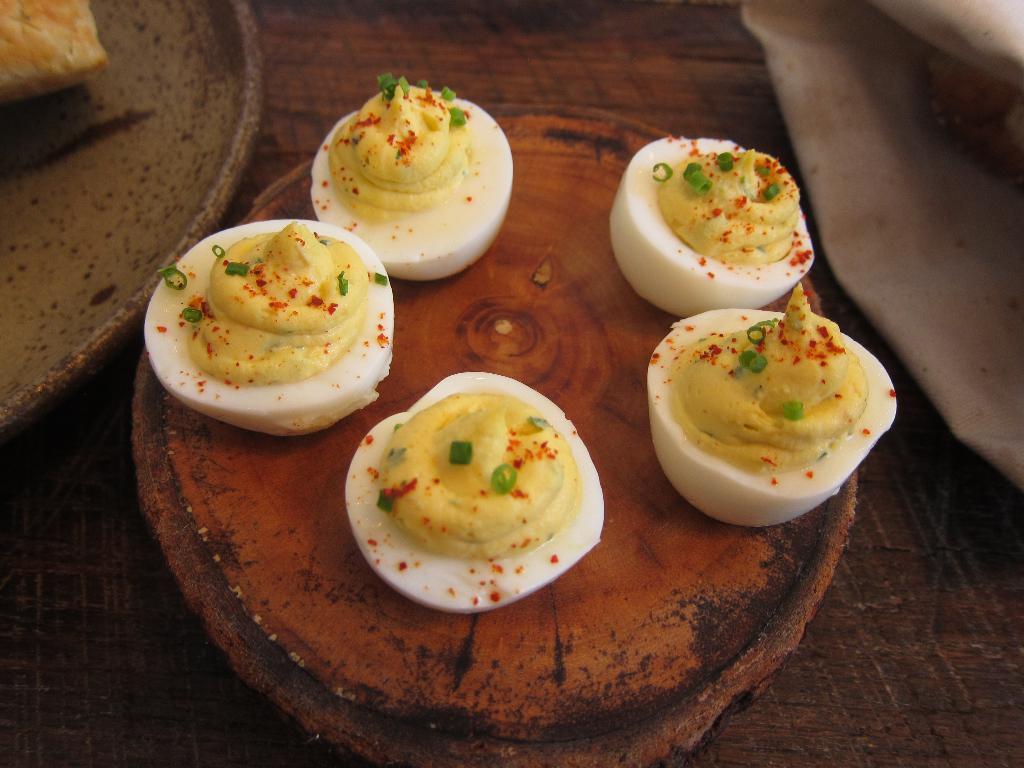In one or two sentences, can you explain what this image depicts? In this picture there are eggs on a wooden tray. 